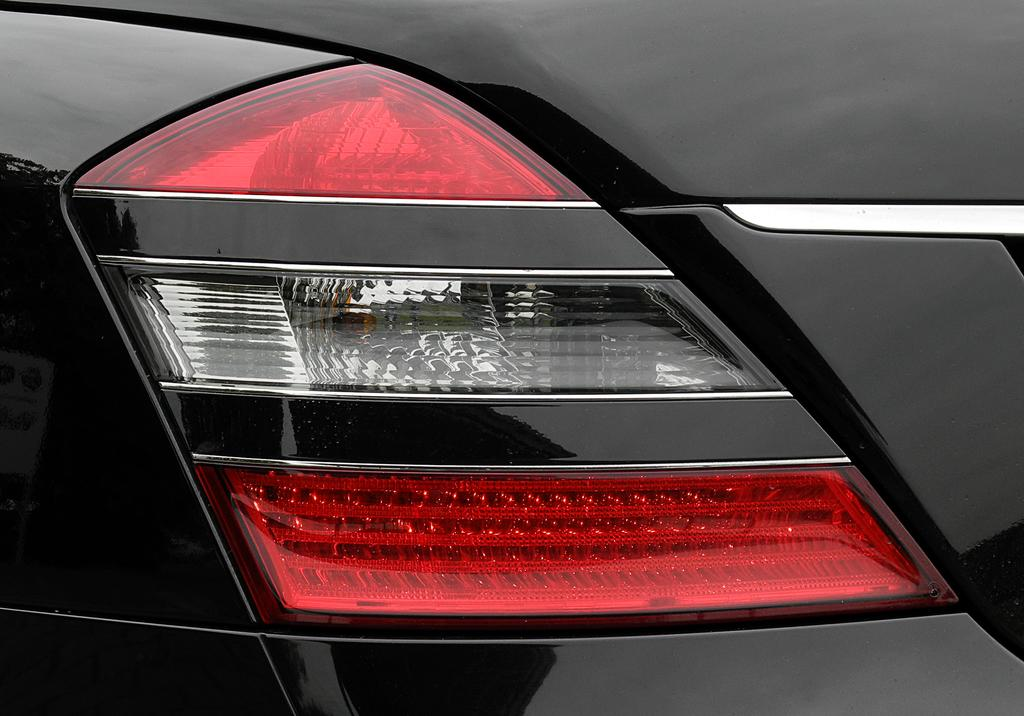What is the main subject of the image? The main subject of the image is the tail lamp of a car. Can you describe the tail lamp in more detail? Unfortunately, the image only shows the tail lamp of a car, and no further details are visible. How many sheep are visible in the image? There are no sheep present in the image; it only features the tail lamp of a car. What is the name of the vase in the image? There is no vase present in the image; it only features the tail lamp of a car. 